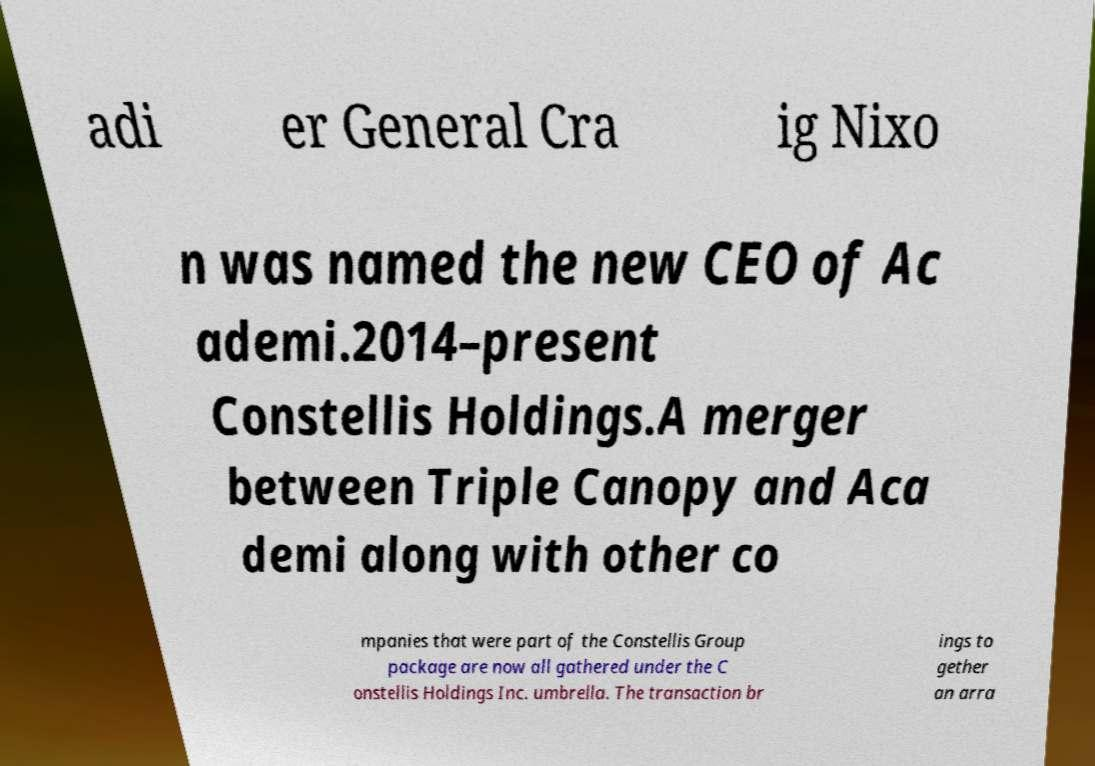There's text embedded in this image that I need extracted. Can you transcribe it verbatim? adi er General Cra ig Nixo n was named the new CEO of Ac ademi.2014–present Constellis Holdings.A merger between Triple Canopy and Aca demi along with other co mpanies that were part of the Constellis Group package are now all gathered under the C onstellis Holdings Inc. umbrella. The transaction br ings to gether an arra 